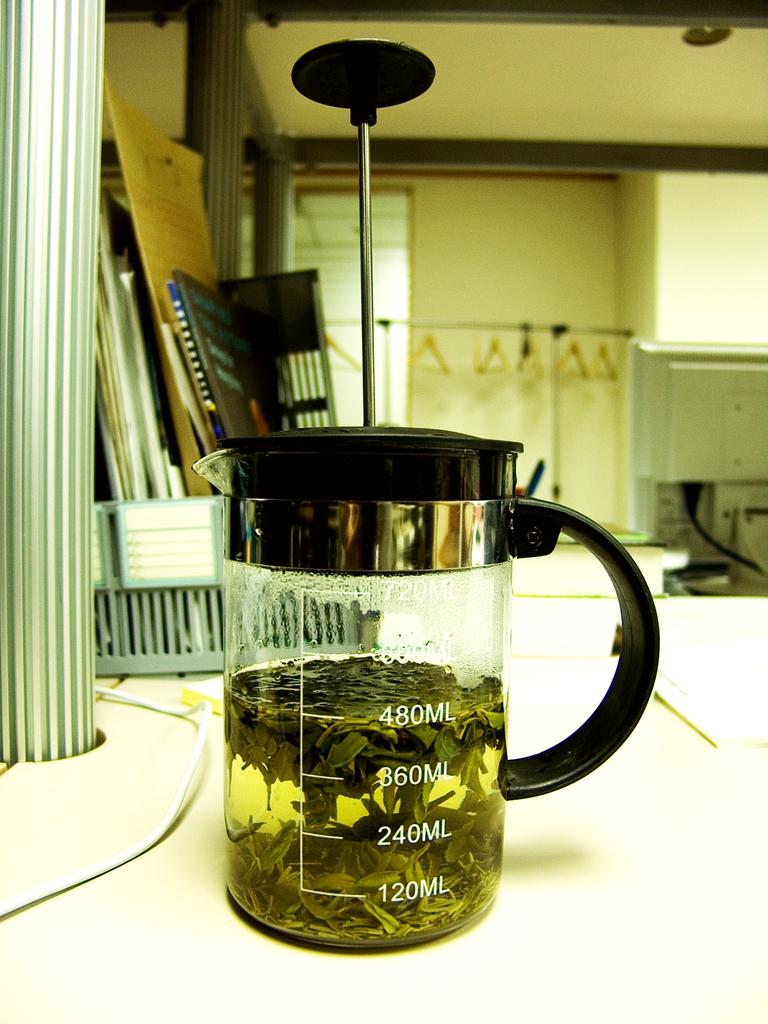What is the lowest meadurement on the cupo?
Your answer should be very brief. 120ml. 